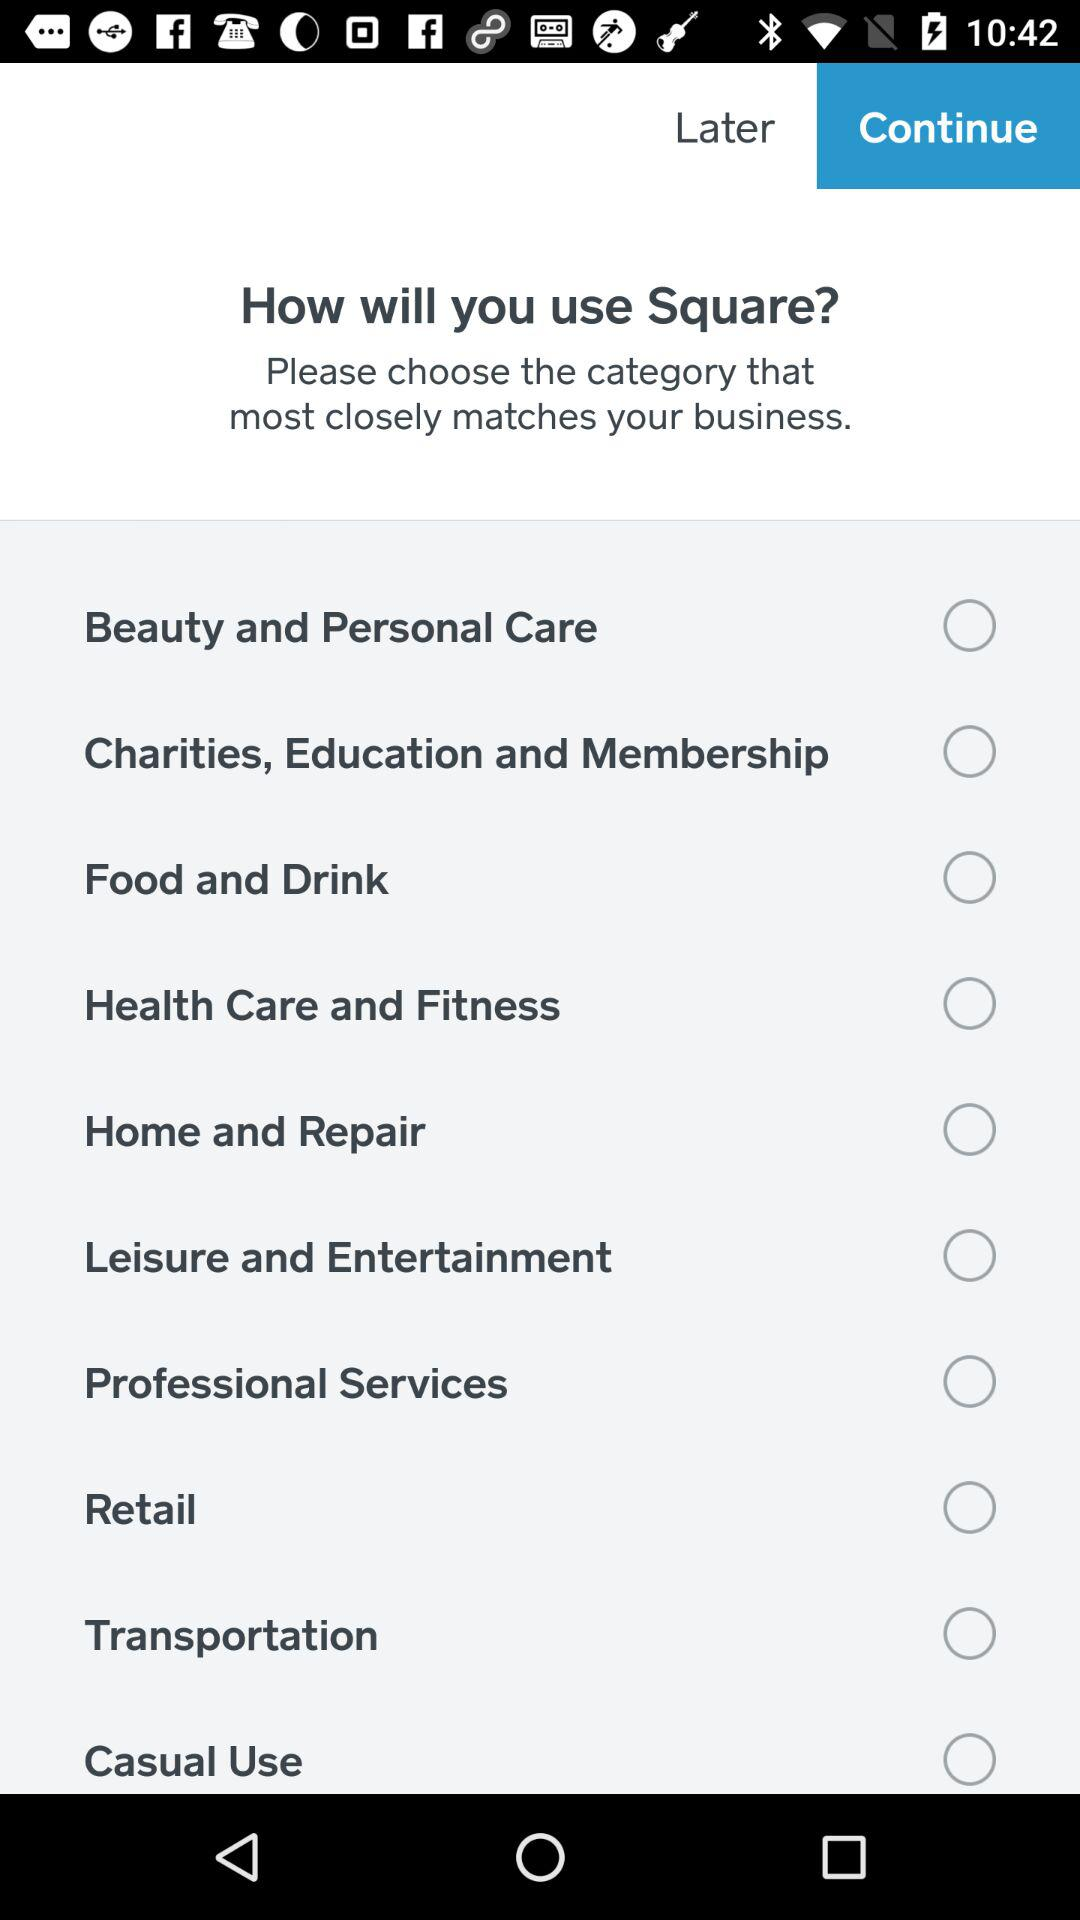How many categories are available for me to choose from?
Answer the question using a single word or phrase. 10 